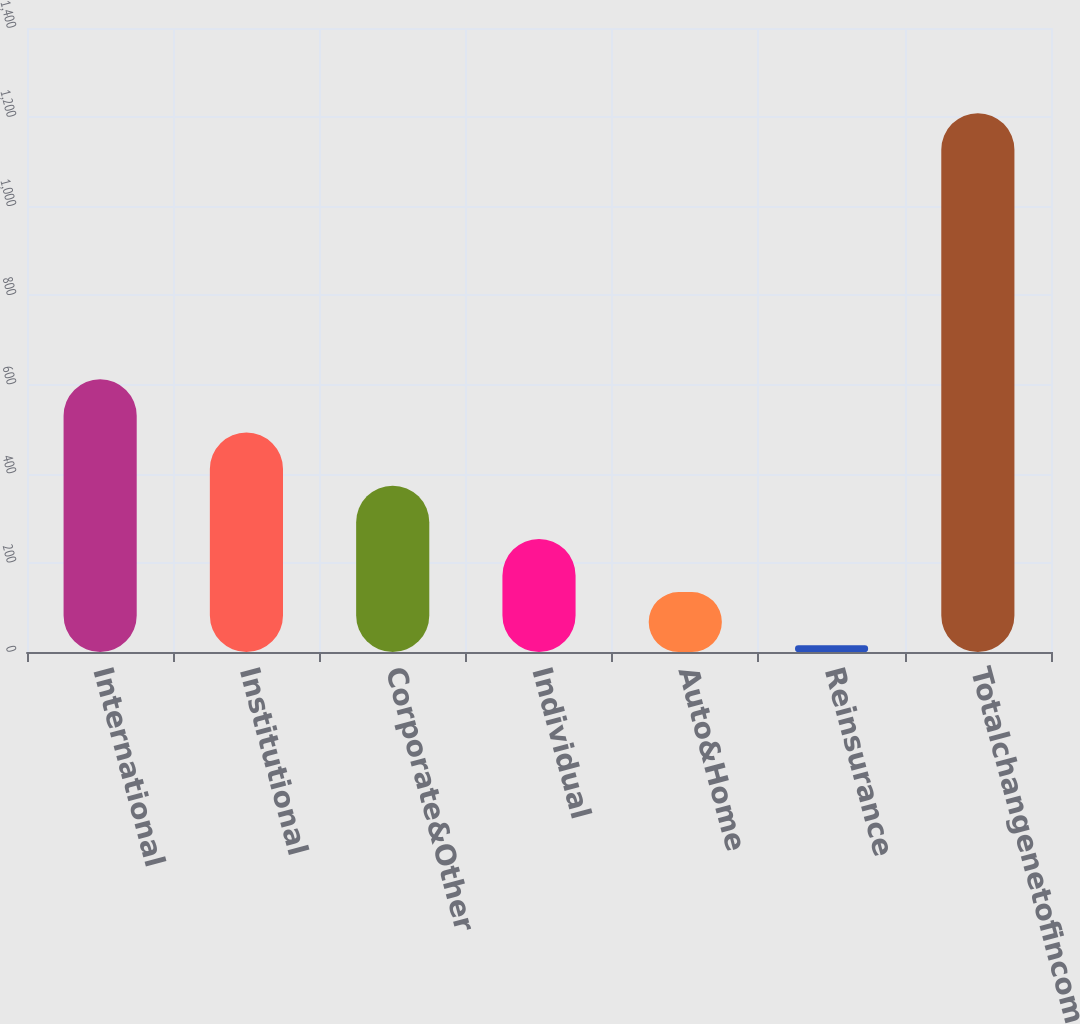Convert chart to OTSL. <chart><loc_0><loc_0><loc_500><loc_500><bar_chart><fcel>International<fcel>Institutional<fcel>Corporate&Other<fcel>Individual<fcel>Auto&Home<fcel>Reinsurance<fcel>Totalchangenetofincometax<nl><fcel>612<fcel>492.6<fcel>373.2<fcel>253.8<fcel>134.4<fcel>15<fcel>1209<nl></chart> 